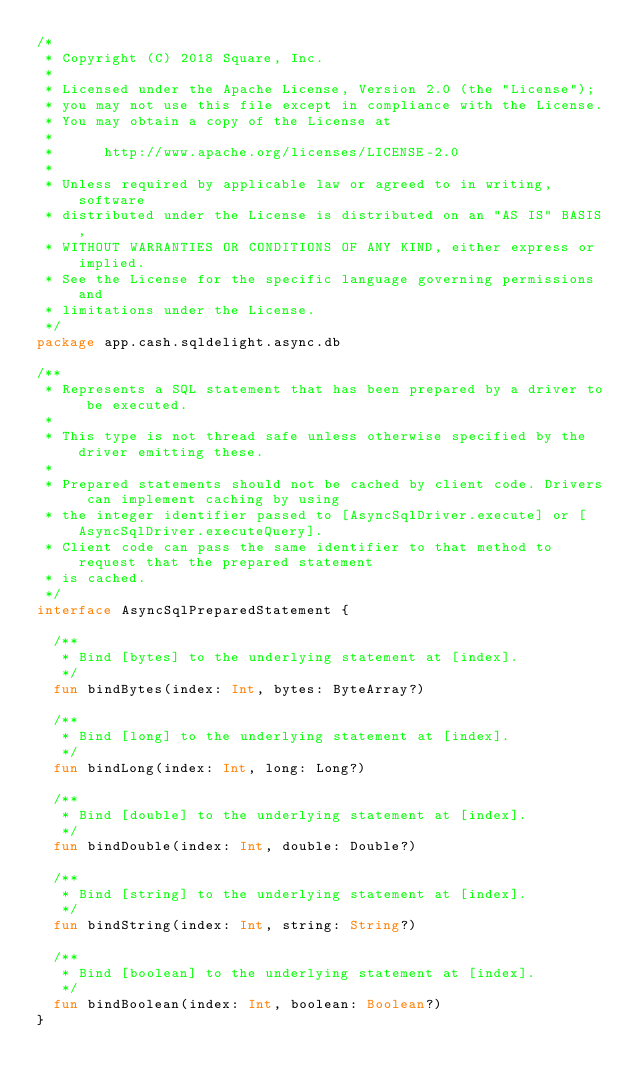<code> <loc_0><loc_0><loc_500><loc_500><_Kotlin_>/*
 * Copyright (C) 2018 Square, Inc.
 *
 * Licensed under the Apache License, Version 2.0 (the "License");
 * you may not use this file except in compliance with the License.
 * You may obtain a copy of the License at
 *
 *      http://www.apache.org/licenses/LICENSE-2.0
 *
 * Unless required by applicable law or agreed to in writing, software
 * distributed under the License is distributed on an "AS IS" BASIS,
 * WITHOUT WARRANTIES OR CONDITIONS OF ANY KIND, either express or implied.
 * See the License for the specific language governing permissions and
 * limitations under the License.
 */
package app.cash.sqldelight.async.db

/**
 * Represents a SQL statement that has been prepared by a driver to be executed.
 *
 * This type is not thread safe unless otherwise specified by the driver emitting these.
 *
 * Prepared statements should not be cached by client code. Drivers can implement caching by using
 * the integer identifier passed to [AsyncSqlDriver.execute] or [AsyncSqlDriver.executeQuery].
 * Client code can pass the same identifier to that method to request that the prepared statement
 * is cached.
 */
interface AsyncSqlPreparedStatement {

  /**
   * Bind [bytes] to the underlying statement at [index].
   */
  fun bindBytes(index: Int, bytes: ByteArray?)

  /**
   * Bind [long] to the underlying statement at [index].
   */
  fun bindLong(index: Int, long: Long?)

  /**
   * Bind [double] to the underlying statement at [index].
   */
  fun bindDouble(index: Int, double: Double?)

  /**
   * Bind [string] to the underlying statement at [index].
   */
  fun bindString(index: Int, string: String?)

  /**
   * Bind [boolean] to the underlying statement at [index].
   */
  fun bindBoolean(index: Int, boolean: Boolean?)
}
</code> 